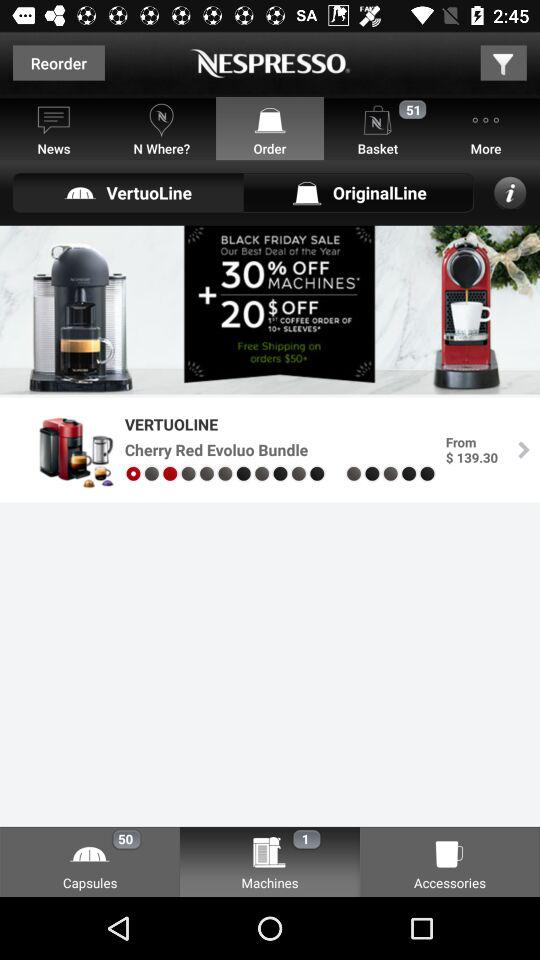How many items are in the basket? There are 51 items in the basket. 